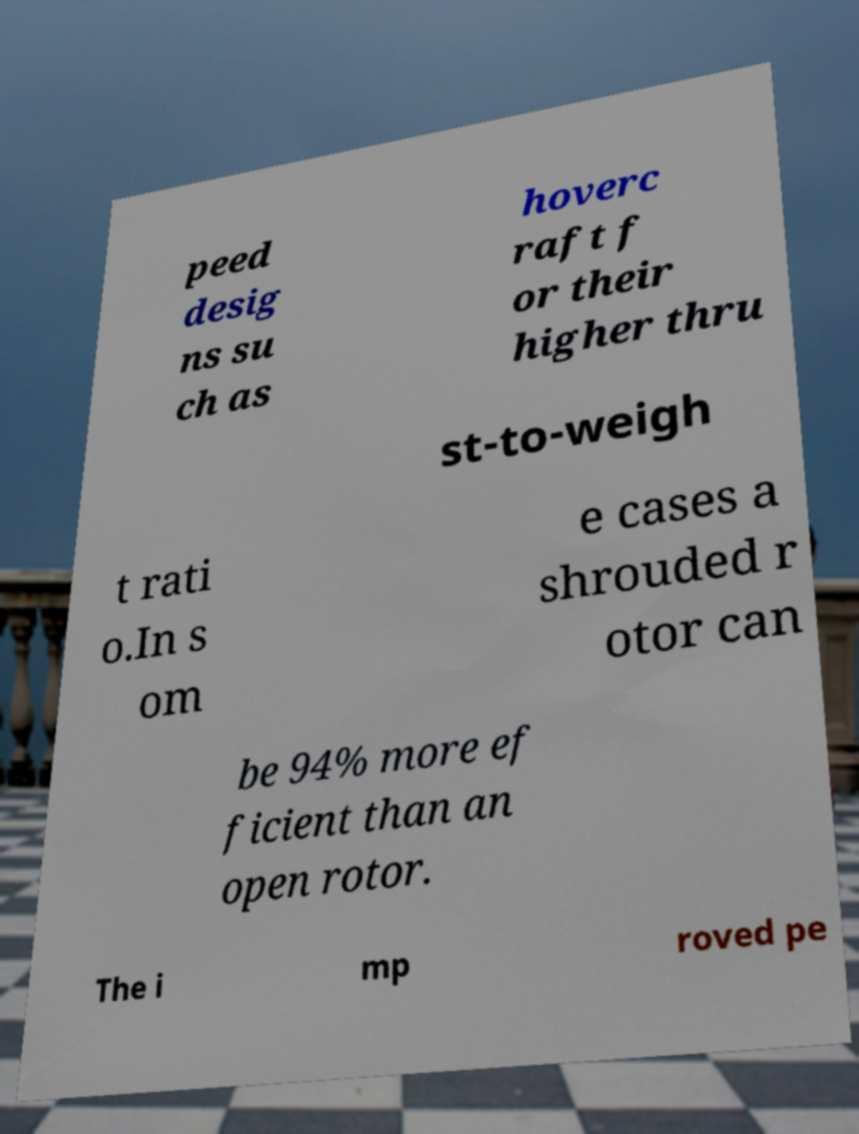Could you extract and type out the text from this image? peed desig ns su ch as hoverc raft f or their higher thru st-to-weigh t rati o.In s om e cases a shrouded r otor can be 94% more ef ficient than an open rotor. The i mp roved pe 